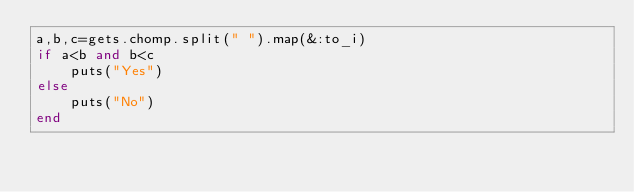Convert code to text. <code><loc_0><loc_0><loc_500><loc_500><_Ruby_>a,b,c=gets.chomp.split(" ").map(&:to_i)
if a<b and b<c
	puts("Yes")
else
	puts("No")
end</code> 